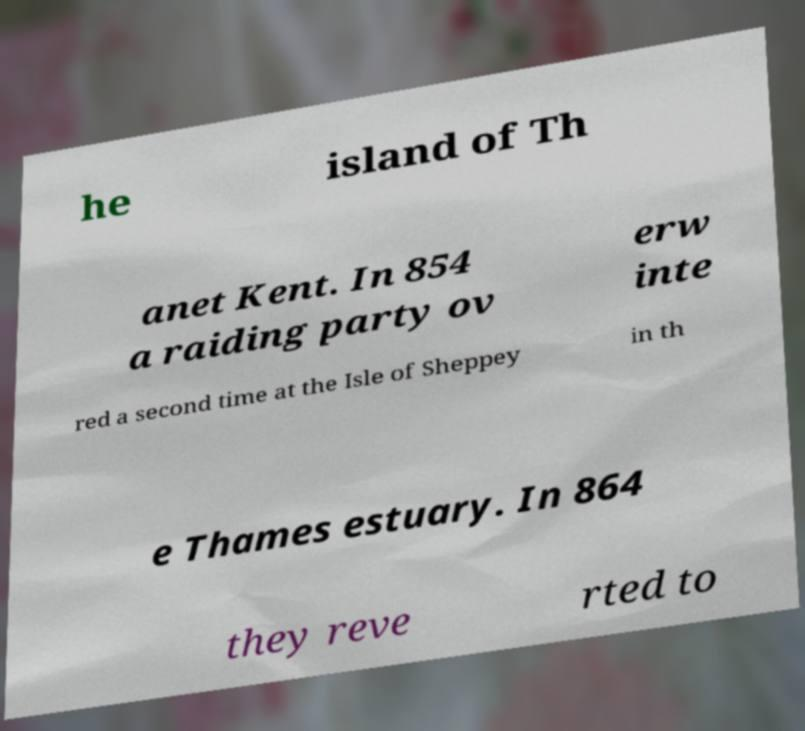Could you assist in decoding the text presented in this image and type it out clearly? he island of Th anet Kent. In 854 a raiding party ov erw inte red a second time at the Isle of Sheppey in th e Thames estuary. In 864 they reve rted to 